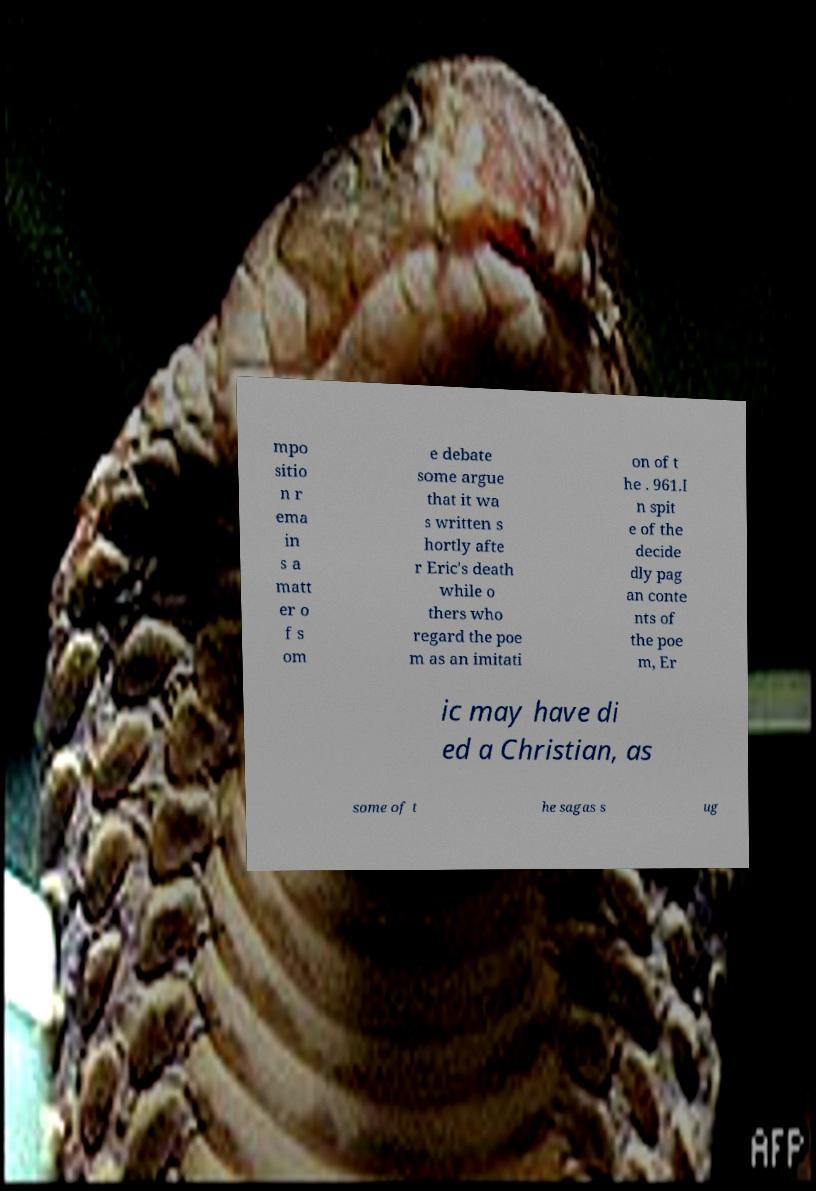There's text embedded in this image that I need extracted. Can you transcribe it verbatim? mpo sitio n r ema in s a matt er o f s om e debate some argue that it wa s written s hortly afte r Eric's death while o thers who regard the poe m as an imitati on of t he . 961.I n spit e of the decide dly pag an conte nts of the poe m, Er ic may have di ed a Christian, as some of t he sagas s ug 